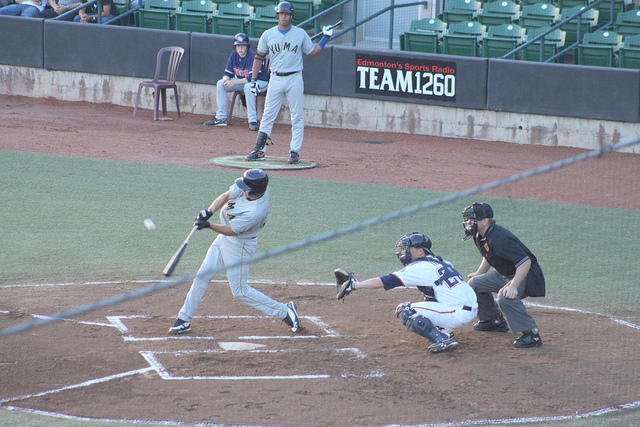Please extract the text content from this image. Edmonton's Sports Radio TEAM1260 YUMA 